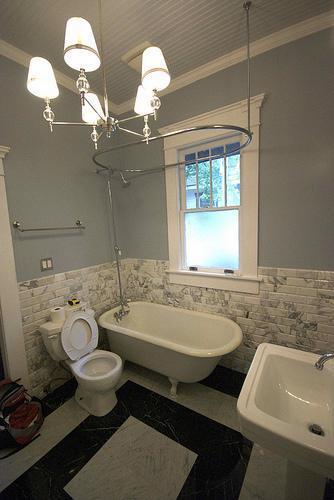How many lights are overhead?
Give a very brief answer. 5. How many panes of glass are in the window?
Give a very brief answer. 9. How many visible walls have a window?
Give a very brief answer. 1. 